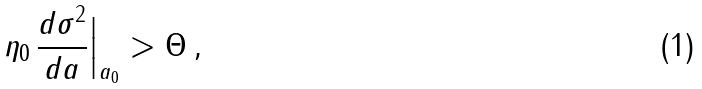Convert formula to latex. <formula><loc_0><loc_0><loc_500><loc_500>\eta _ { 0 } \, \frac { d \sigma ^ { 2 } } { d a } \Big | _ { a _ { 0 } } > \Theta \, ,</formula> 